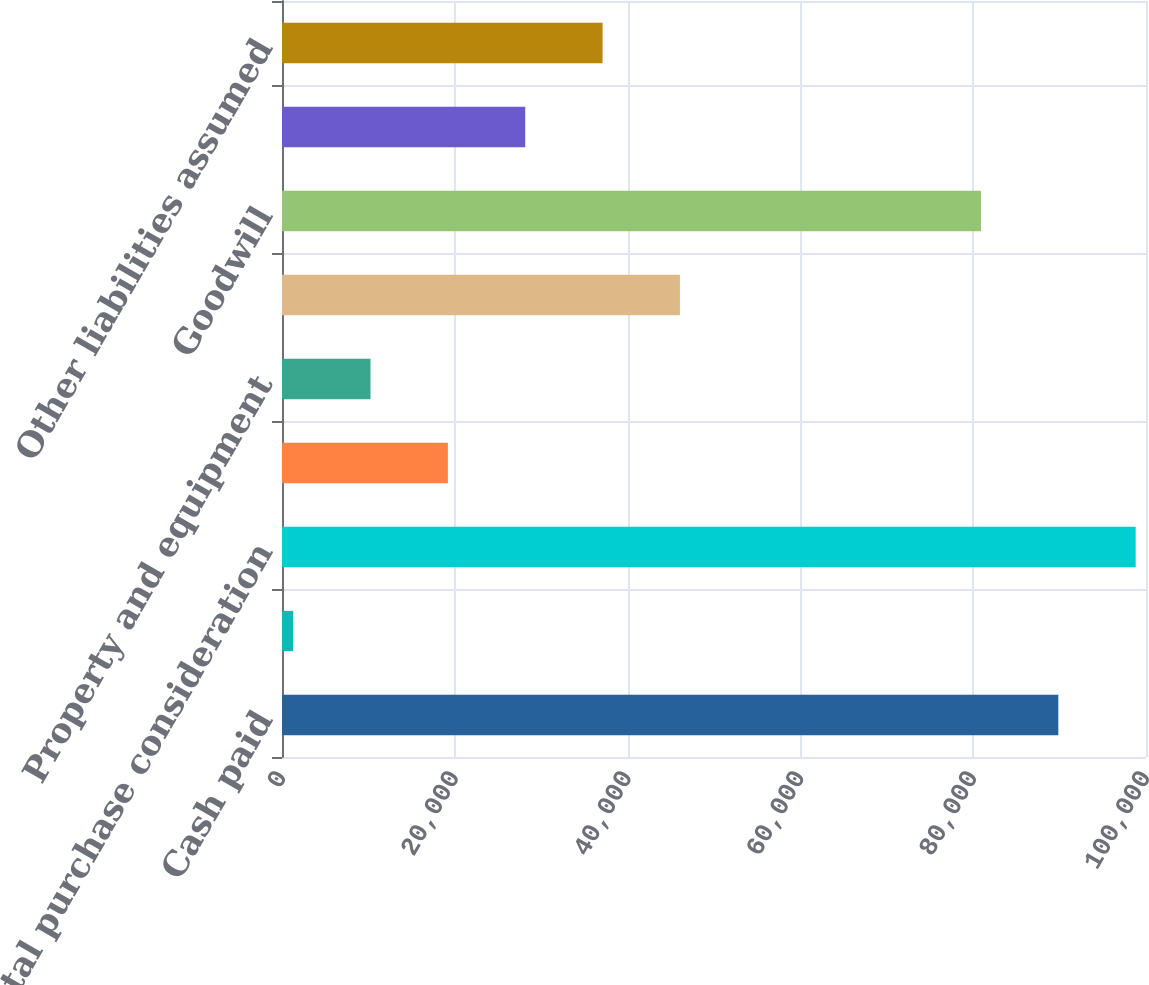Convert chart. <chart><loc_0><loc_0><loc_500><loc_500><bar_chart><fcel>Cash paid<fcel>Transaction costs<fcel>Total purchase consideration<fcel>Current assets<fcel>Property and equipment<fcel>Identifiable intangible assets<fcel>Goodwill<fcel>Deferred tax liabilities<fcel>Other liabilities assumed<nl><fcel>89853<fcel>1294<fcel>98805<fcel>19198<fcel>10246<fcel>46054<fcel>80901<fcel>28150<fcel>37102<nl></chart> 